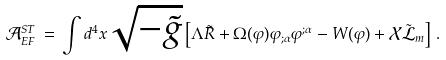<formula> <loc_0><loc_0><loc_500><loc_500>\mathcal { A } _ { E F } ^ { S T } \, = \, \int d ^ { 4 } x \sqrt { - \tilde { g } } \left [ \Lambda \tilde { R } + \Omega ( \varphi ) \varphi _ { ; \alpha } \varphi ^ { ; \alpha } - W ( \varphi ) + \mathcal { X } \tilde { \mathcal { L } } _ { m } \right ] \, .</formula> 